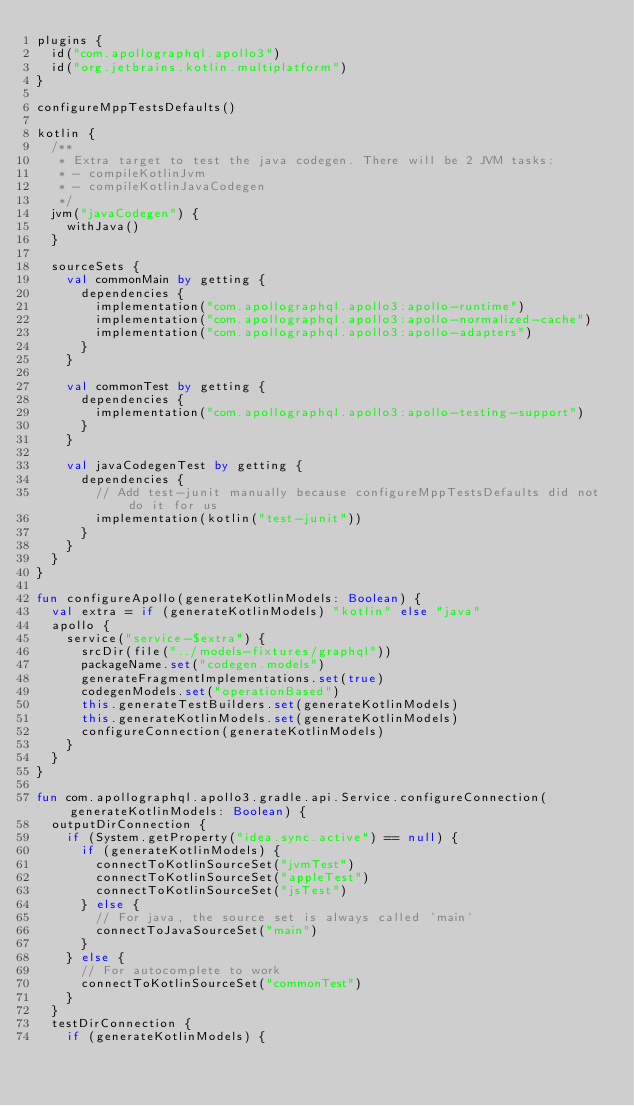<code> <loc_0><loc_0><loc_500><loc_500><_Kotlin_>plugins {
  id("com.apollographql.apollo3")
  id("org.jetbrains.kotlin.multiplatform")
}

configureMppTestsDefaults()

kotlin {
  /**
   * Extra target to test the java codegen. There will be 2 JVM tasks:
   * - compileKotlinJvm
   * - compileKotlinJavaCodegen
   */
  jvm("javaCodegen") {
    withJava()
  }

  sourceSets {
    val commonMain by getting {
      dependencies {
        implementation("com.apollographql.apollo3:apollo-runtime")
        implementation("com.apollographql.apollo3:apollo-normalized-cache")
        implementation("com.apollographql.apollo3:apollo-adapters")
      }
    }

    val commonTest by getting {
      dependencies {
        implementation("com.apollographql.apollo3:apollo-testing-support")
      }
    }

    val javaCodegenTest by getting {
      dependencies {
        // Add test-junit manually because configureMppTestsDefaults did not do it for us
        implementation(kotlin("test-junit"))
      }
    }
  }
}

fun configureApollo(generateKotlinModels: Boolean) {
  val extra = if (generateKotlinModels) "kotlin" else "java"
  apollo {
    service("service-$extra") {
      srcDir(file("../models-fixtures/graphql"))
      packageName.set("codegen.models")
      generateFragmentImplementations.set(true)
      codegenModels.set("operationBased")
      this.generateTestBuilders.set(generateKotlinModels)
      this.generateKotlinModels.set(generateKotlinModels)
      configureConnection(generateKotlinModels)
    }
  }
}

fun com.apollographql.apollo3.gradle.api.Service.configureConnection(generateKotlinModels: Boolean) {
  outputDirConnection {
    if (System.getProperty("idea.sync.active") == null) {
      if (generateKotlinModels) {
        connectToKotlinSourceSet("jvmTest")
        connectToKotlinSourceSet("appleTest")
        connectToKotlinSourceSet("jsTest")
      } else {
        // For java, the source set is always called 'main'
        connectToJavaSourceSet("main")
      }
    } else {
      // For autocomplete to work
      connectToKotlinSourceSet("commonTest")
    }
  }
  testDirConnection {
    if (generateKotlinModels) {</code> 